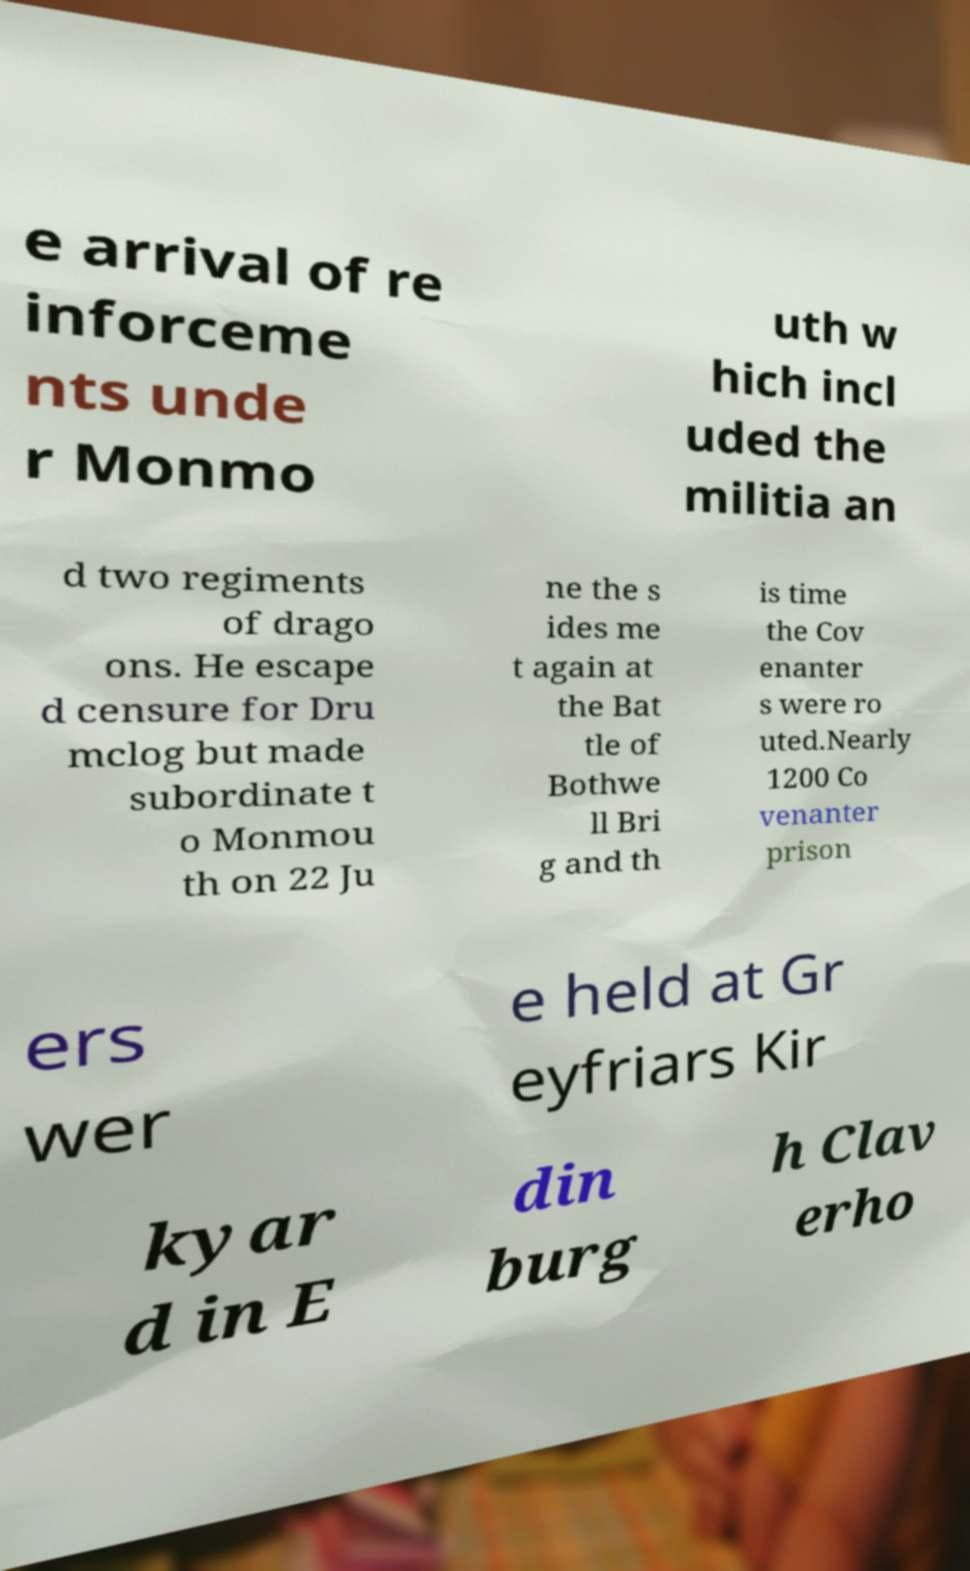I need the written content from this picture converted into text. Can you do that? e arrival of re inforceme nts unde r Monmo uth w hich incl uded the militia an d two regiments of drago ons. He escape d censure for Dru mclog but made subordinate t o Monmou th on 22 Ju ne the s ides me t again at the Bat tle of Bothwe ll Bri g and th is time the Cov enanter s were ro uted.Nearly 1200 Co venanter prison ers wer e held at Gr eyfriars Kir kyar d in E din burg h Clav erho 